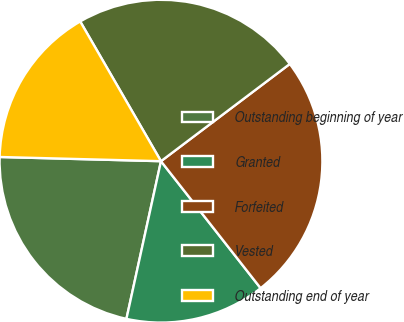<chart> <loc_0><loc_0><loc_500><loc_500><pie_chart><fcel>Outstanding beginning of year<fcel>Granted<fcel>Forfeited<fcel>Vested<fcel>Outstanding end of year<nl><fcel>21.98%<fcel>14.02%<fcel>24.7%<fcel>23.05%<fcel>16.24%<nl></chart> 